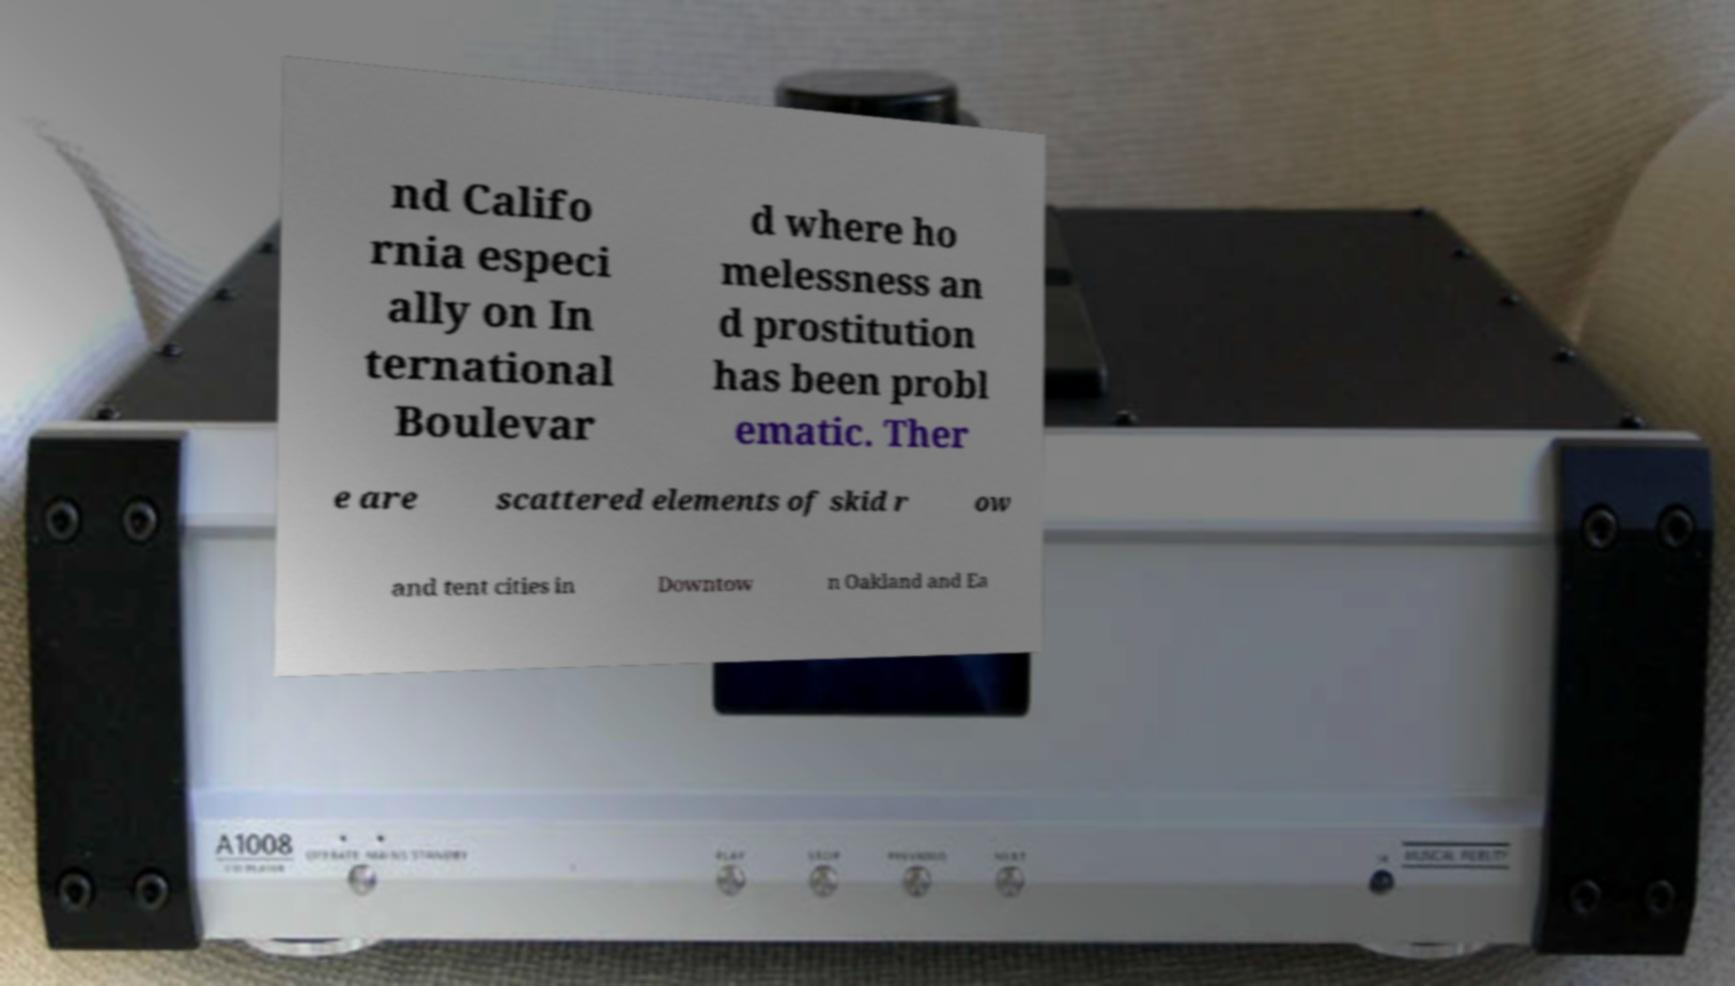Could you assist in decoding the text presented in this image and type it out clearly? nd Califo rnia especi ally on In ternational Boulevar d where ho melessness an d prostitution has been probl ematic. Ther e are scattered elements of skid r ow and tent cities in Downtow n Oakland and Ea 